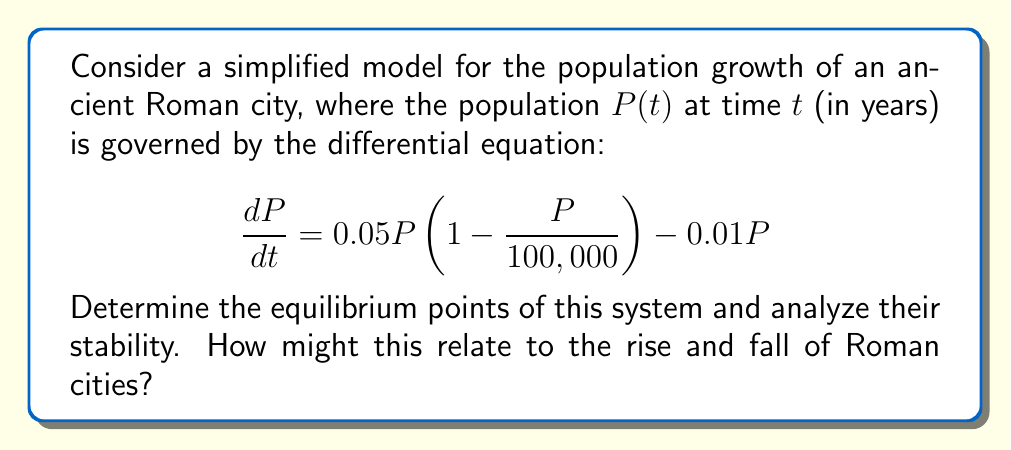Show me your answer to this math problem. Let's approach this step-by-step:

1) First, we need to find the equilibrium points. These occur when $\frac{dP}{dt} = 0$. So, we set the equation equal to zero:

   $$0.05P\left(1 - \frac{P}{100,000}\right) - 0.01P = 0$$

2) Factoring out $P$:

   $$P\left[0.05\left(1 - \frac{P}{100,000}\right) - 0.01\right] = 0$$

3) This equation is satisfied when $P = 0$ or when the term in brackets is zero. Let's solve the latter:

   $$0.05\left(1 - \frac{P}{100,000}\right) - 0.01 = 0$$
   $$0.05 - \frac{0.05P}{100,000} - 0.01 = 0$$
   $$0.04 - \frac{0.05P}{100,000} = 0$$
   $$0.04 = \frac{0.05P}{100,000}$$
   $$80,000 = P$$

4) So, our equilibrium points are $P_1 = 0$ and $P_2 = 80,000$.

5) To analyze stability, we need to look at the derivative of $\frac{dP}{dt}$ with respect to $P$ at each equilibrium point:

   $$\frac{d}{dP}\left(\frac{dP}{dt}\right) = 0.05\left(1 - \frac{2P}{100,000}\right) - 0.01$$

6) At $P_1 = 0$:
   $$\frac{d}{dP}\left(\frac{dP}{dt}\right)\bigg|_{P=0} = 0.05 - 0.01 = 0.04 > 0$$
   This is positive, so $P_1 = 0$ is an unstable equilibrium.

7) At $P_2 = 80,000$:
   $$\frac{d}{dP}\left(\frac{dP}{dt}\right)\bigg|_{P=80,000} = 0.05\left(1 - \frac{2(80,000)}{100,000}\right) - 0.01 = -0.04 < 0$$
   This is negative, so $P_2 = 80,000$ is a stable equilibrium.

8) Historically, this could represent how Roman cities tended to grow from small settlements (unstable equilibrium at 0) towards a stable population (stable equilibrium at 80,000). The stable equilibrium might represent the city's carrying capacity based on resources and infrastructure.
Answer: Two equilibrium points: $P_1 = 0$ (unstable) and $P_2 = 80,000$ (stable). 